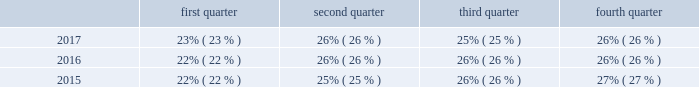Research and development we are committed to investing in highly productive research and development capabilities , particularly in electro-mechanical systems .
Our research and development ( "r&d" ) expenditures were approximately $ 48.3 million , $ 47.3 million and $ 45.2 million for the years ended december 31 , 2017 , 2016 and 2015 , respectively .
We concentrate on developing technology innovations that will deliver growth through the introduction of new products and solutions , and also on driving continuous improvements in product cost , quality , safety and sustainability .
We manage our r&d team as a global group with an emphasis on a global collaborative approach to identify and develop new technologies and worldwide product platforms .
We are organized on a regional basis to leverage expertise in local standards and configurations .
In addition to regional engineering centers in each geographic region , we also operate a global engineering center of excellence in bangalore , india .
Seasonality our business experiences seasonality that varies by product line .
Because more construction and do-it-yourself projects occur during the second and third calendar quarters of each year in the northern hemisphere , our security product sales , typically , are higher in those quarters than in the first and fourth calendar quarters .
However , our interflex business typically experiences higher sales in the fourth calendar quarter due to project timing .
Revenue by quarter for the years ended december 31 , 2017 , 2016 and 2015 are as follows: .
Employees we currently have approximately 10000 employees .
Environmental regulation we have a dedicated environmental program that is designed to reduce the utilization and generation of hazardous materials during the manufacturing process as well as to remediate identified environmental concerns .
As to the latter , we are currently engaged in site investigations and remediation activities to address environmental cleanup from past operations at current and former production facilities .
The company regularly evaluates its remediation programs and considers alternative remediation methods that are in addition to , or in replacement of , those currently utilized by the company based upon enhanced technology and regulatory changes .
We are sometimes a party to environmental lawsuits and claims and have received notices of potential violations of environmental laws and regulations from the u.s .
Environmental protection agency ( the "epa" ) and similar state authorities .
We have also been identified as a potentially responsible party ( "prp" ) for cleanup costs associated with off-site waste disposal at federal superfund and state remediation sites .
For all such sites , there are other prps and , in most instances , our involvement is minimal .
In estimating our liability , we have assumed that we will not bear the entire cost of remediation of any site to the exclusion of other prps who may be jointly and severally liable .
The ability of other prps to participate has been taken into account , based on our understanding of the parties 2019 financial condition and probable contributions on a per site basis .
Additional lawsuits and claims involving environmental matters are likely to arise from time to time in the future .
We incurred $ 3.2 million , $ 23.3 million , and $ 4.4 million of expenses during the years ended december 31 , 2017 , 2016 , and 2015 , respectively , for environmental remediation at sites presently or formerly owned or leased by us .
As of december 31 , 2017 and 2016 , we have recorded reserves for environmental matters of $ 28.9 million and $ 30.6 million .
Of these amounts $ 8.9 million and $ 9.6 million , respectively , relate to remediation of sites previously disposed by us .
Given the evolving nature of environmental laws , regulations and technology , the ultimate cost of future compliance is uncertain. .
Considering the years 2016-2017 , what is the average value recorded for reserves for environmental matters , in millions of dollars? 
Rationale: it is the sum of the reserves available during 2016 and 2017 divided by two ( the period of years ) .
Computations: ((28.9 + 30.6) / 2)
Answer: 29.75. 